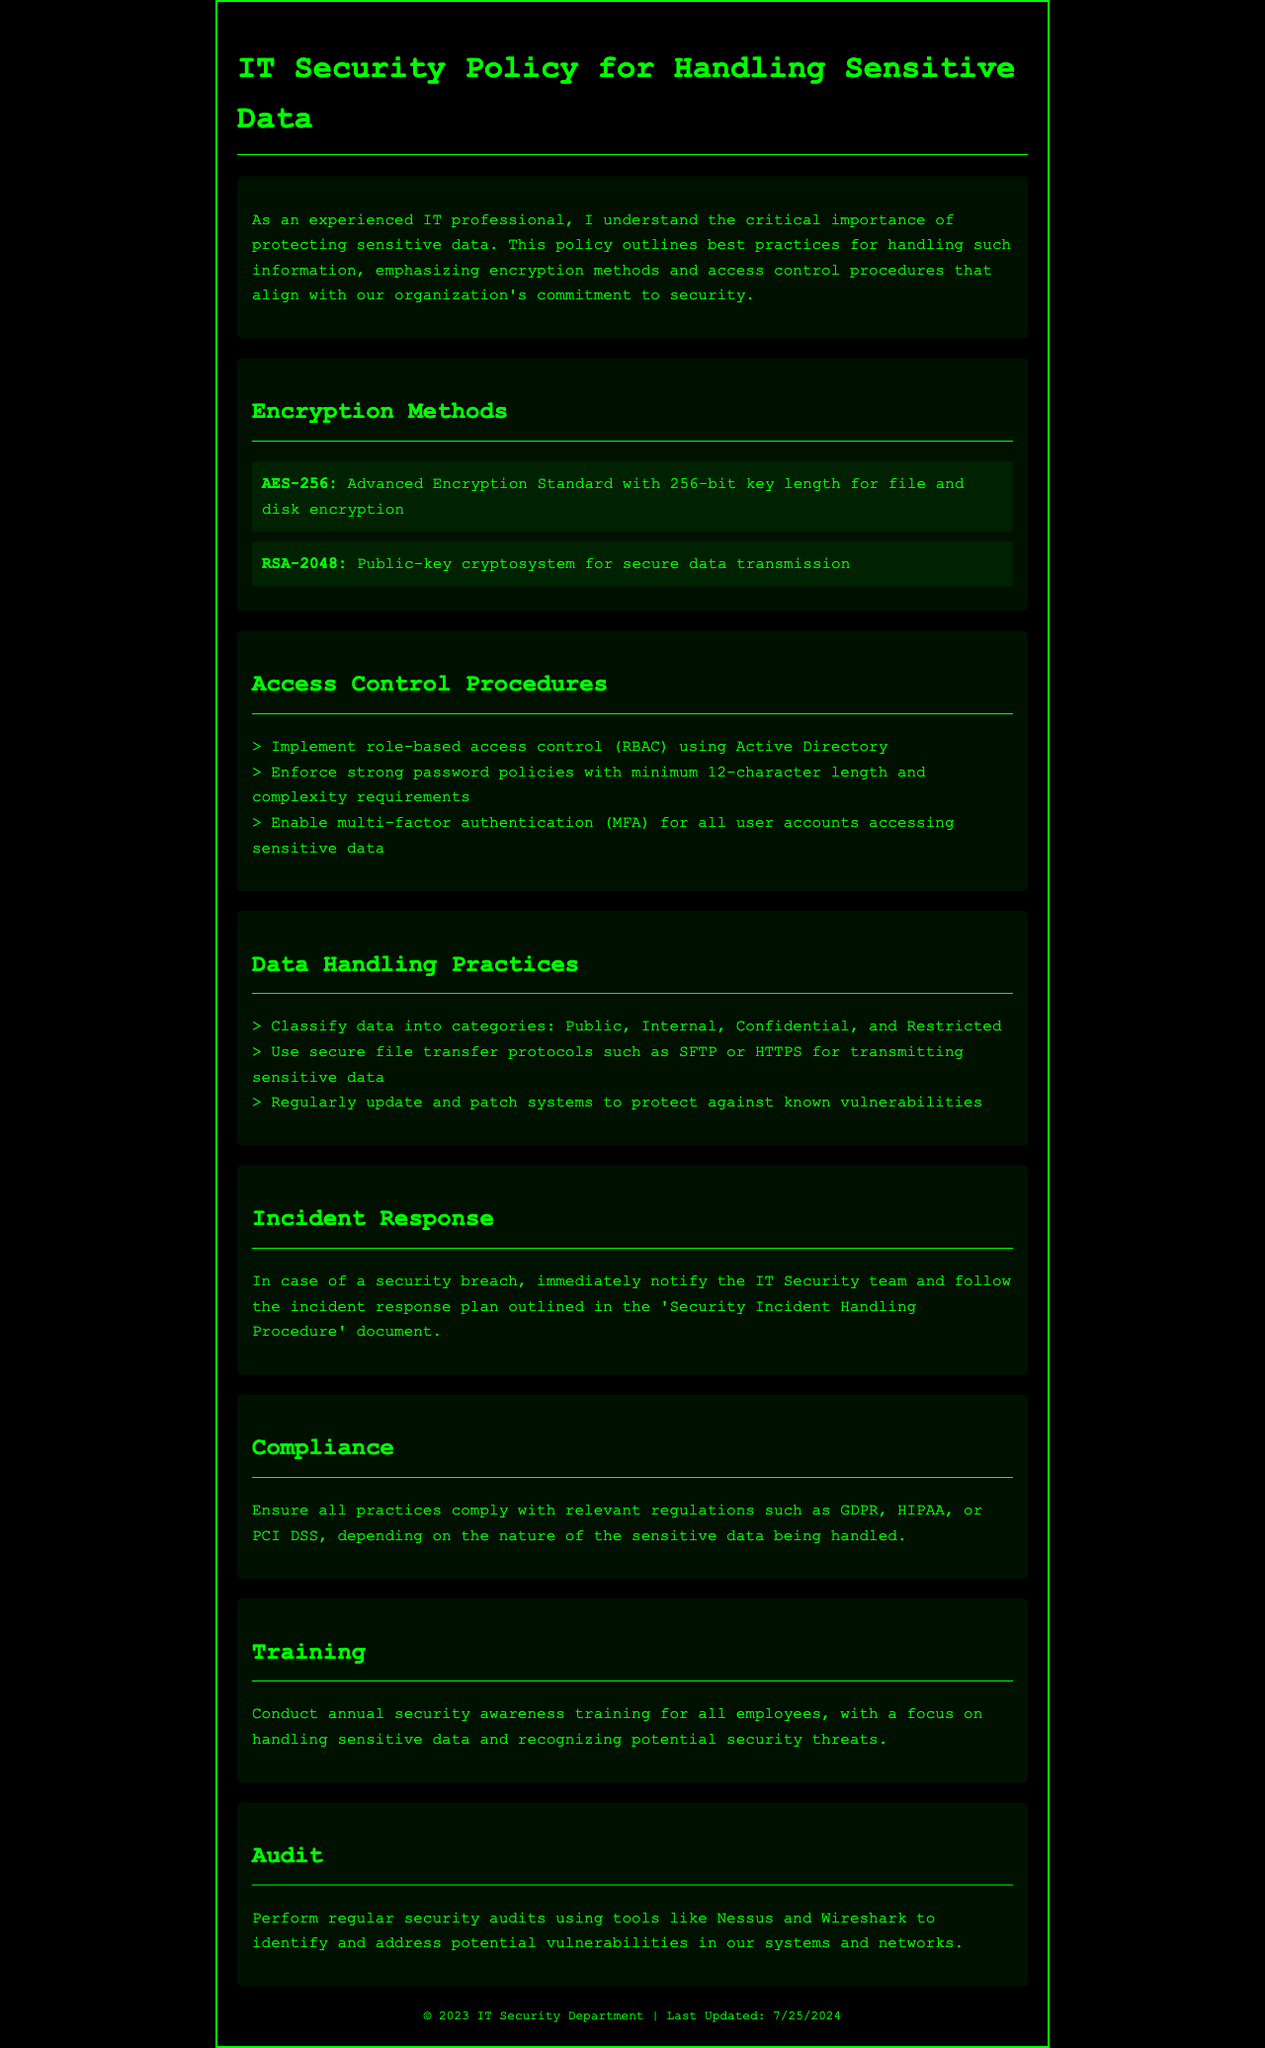What is the encryption standard mentioned for file and disk encryption? The document specifies AES-256 as the encryption standard for file and disk encryption.
Answer: AES-256 What is the minimum password length policy? The document states that strong password policies should require a minimum length of 12 characters.
Answer: 12 characters What cryptosystem is used for secure data transmission? The policy mentions RSA-2048 as the cryptosystem for secure data transmission.
Answer: RSA-2048 What category is specifically focused on by the annual security training? The training focuses on handling sensitive data and recognizing potential security threats.
Answer: Handling sensitive data How often should security audits be performed? The document implies that security audits should be regular but does not specify an exact frequency.
Answer: Regularly Which method of authentication is required for accessing sensitive data? The document mandates the use of multi-factor authentication for all user accounts accessing sensitive data.
Answer: Multi-factor authentication What should be immediately done in case of a security breach? The policy instructs to immediately notify the IT Security team in case of a security breach.
Answer: Notify the IT Security team What are the classifications of data mentioned in the document? The document classifies data into four categories: Public, Internal, Confidential, and Restricted.
Answer: Public, Internal, Confidential, Restricted Which tools are recommended for regular security audits? The document recommends using Nessus and Wireshark for regular security audits.
Answer: Nessus and Wireshark 